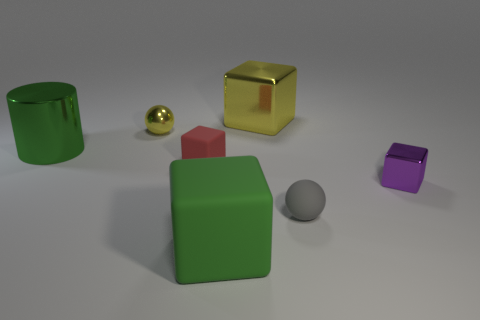Are there any patterns or consistency in the arrangement of the objects? At a glance, the objects seem to be placed randomly. However, upon closer inspection, one might observe that there's a subtle gradation in size from the larger objects in the foreground to the smaller ones towards the back, giving a sense of depth to the composition. 